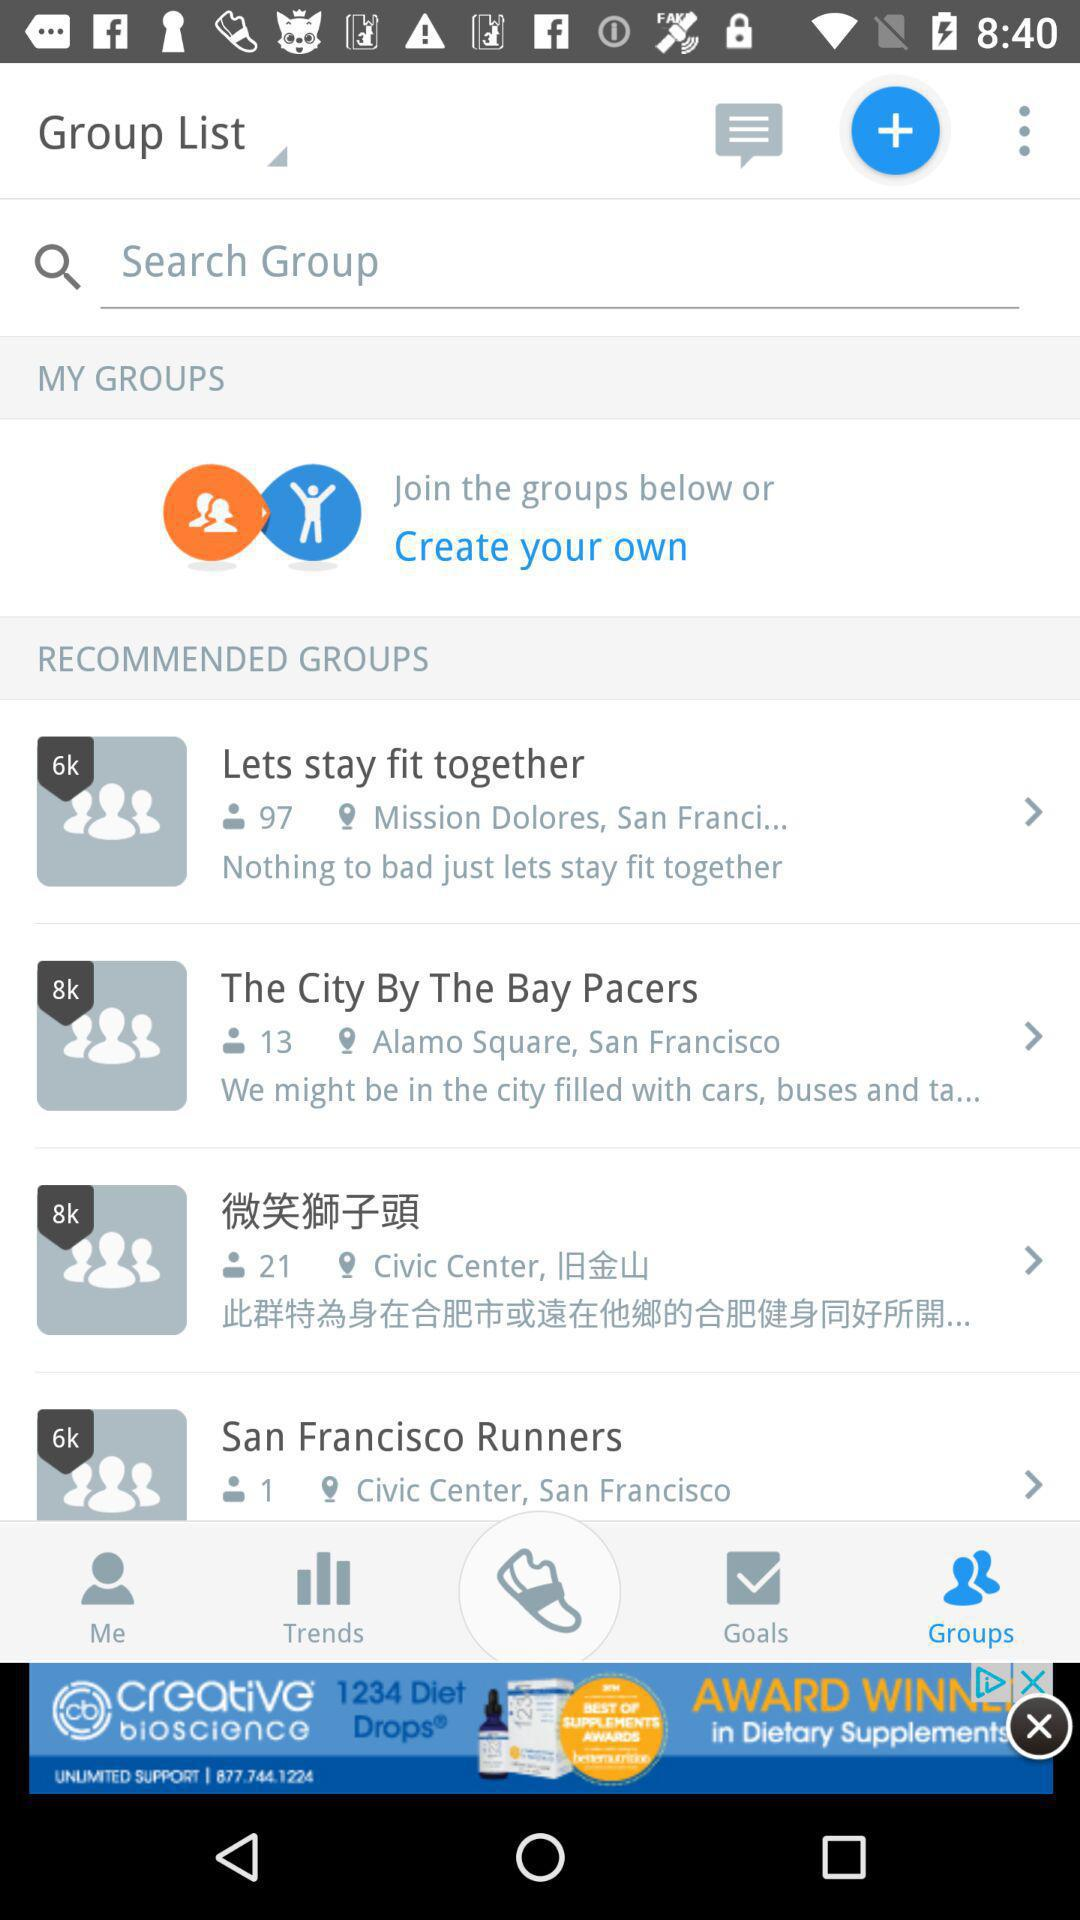What is the address given for the "Lets stay fit together"? The address given for the "Lets stay fit together" is "Mission Dolores, San Franci...". 